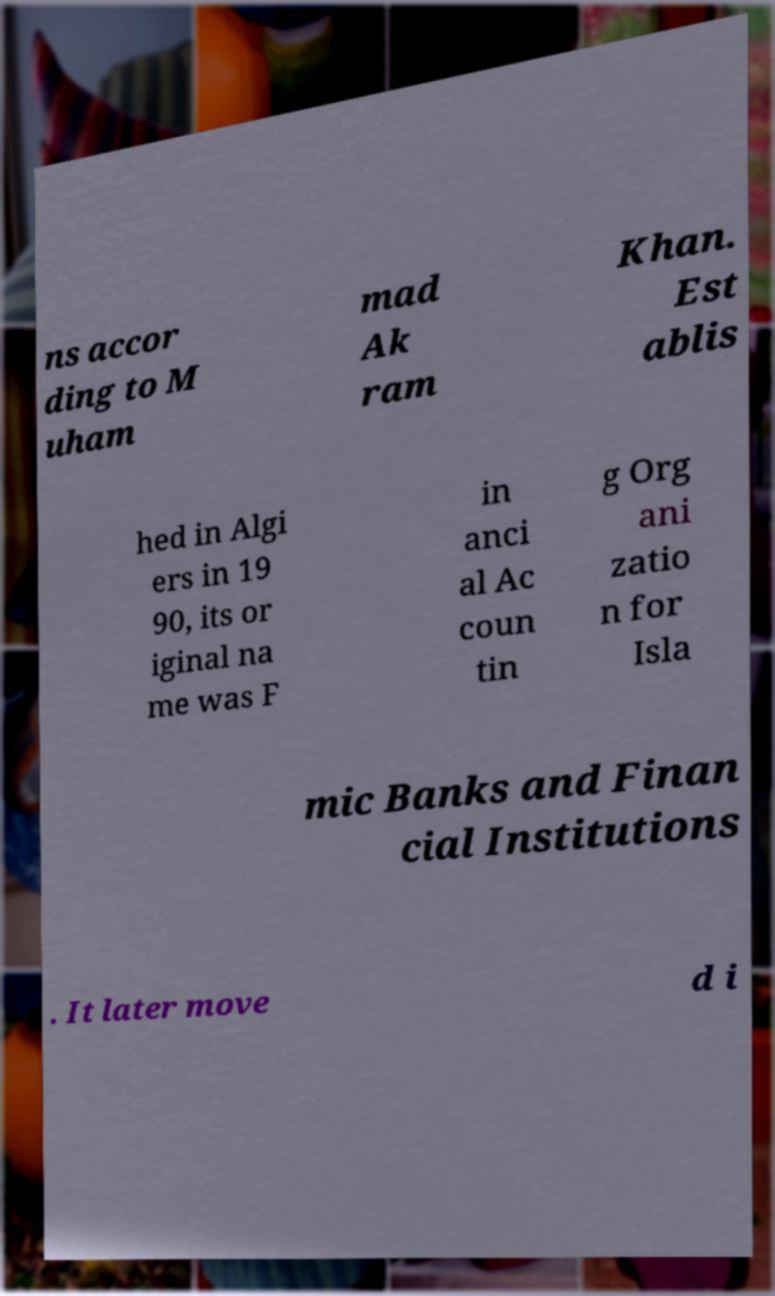Please identify and transcribe the text found in this image. ns accor ding to M uham mad Ak ram Khan. Est ablis hed in Algi ers in 19 90, its or iginal na me was F in anci al Ac coun tin g Org ani zatio n for Isla mic Banks and Finan cial Institutions . It later move d i 